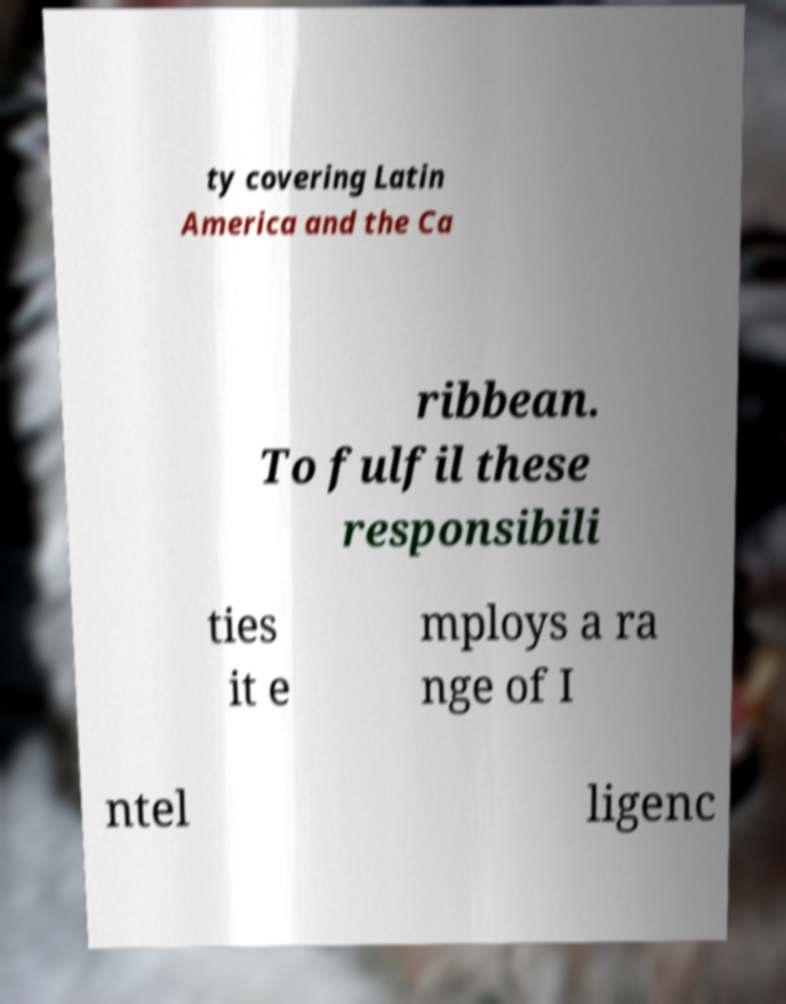Could you assist in decoding the text presented in this image and type it out clearly? ty covering Latin America and the Ca ribbean. To fulfil these responsibili ties it e mploys a ra nge of I ntel ligenc 